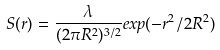<formula> <loc_0><loc_0><loc_500><loc_500>S ( r ) = \frac { \lambda } { ( 2 { \pi } R ^ { 2 } ) ^ { 3 / 2 } } e x p ( - r ^ { 2 } / 2 R ^ { 2 } )</formula> 